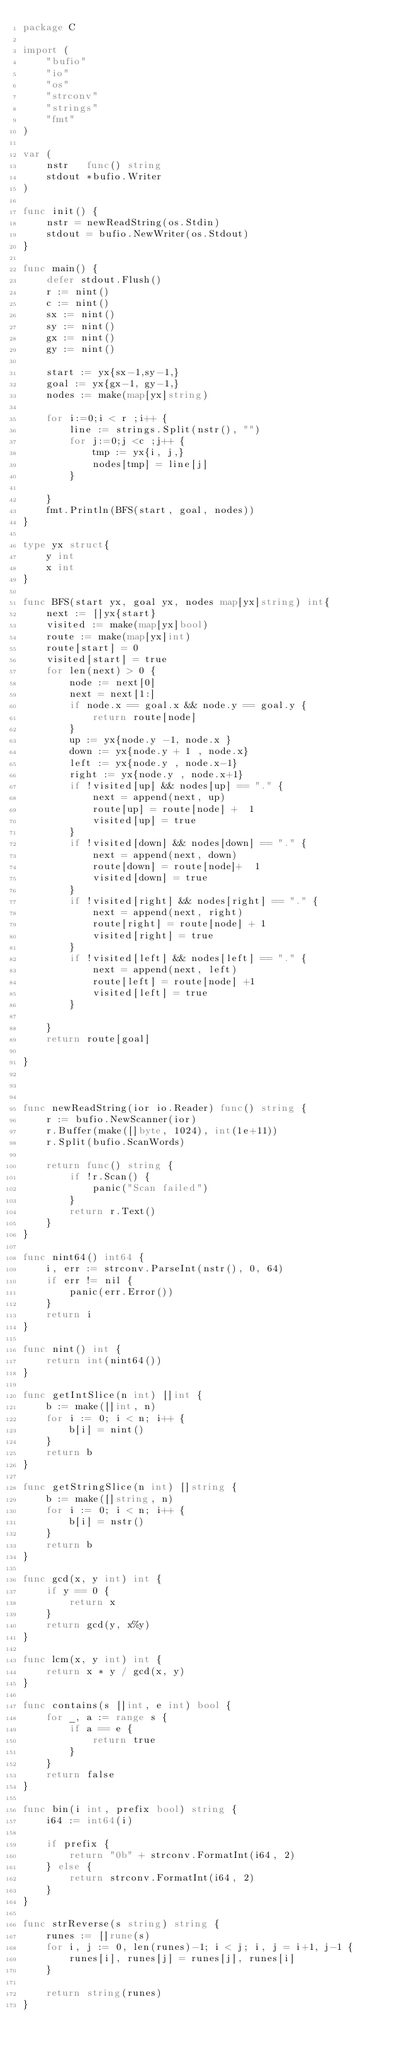<code> <loc_0><loc_0><loc_500><loc_500><_Go_>package C

import (
	"bufio"
	"io"
	"os"
	"strconv"
	"strings"
	"fmt"
)

var (
	nstr   func() string
	stdout *bufio.Writer
)

func init() {
	nstr = newReadString(os.Stdin)
	stdout = bufio.NewWriter(os.Stdout)
}

func main() {
	defer stdout.Flush()
	r := nint()
	c := nint()
	sx := nint()
	sy := nint()
	gx := nint()
	gy := nint()

	start := yx{sx-1,sy-1,}
	goal := yx{gx-1, gy-1,}
	nodes := make(map[yx]string)

	for i:=0;i < r ;i++ {
		line := strings.Split(nstr(), "")
		for j:=0;j <c ;j++ {
			tmp := yx{i, j,}
			nodes[tmp] = line[j]
		}

	}
	fmt.Println(BFS(start, goal, nodes))
}

type yx struct{
	y int
	x int
}

func BFS(start yx, goal yx, nodes map[yx]string) int{
	next := []yx{start}
	visited := make(map[yx]bool)
	route := make(map[yx]int)
	route[start] = 0
	visited[start] = true
	for len(next) > 0 {
		node := next[0]
		next = next[1:]
		if node.x == goal.x && node.y == goal.y {
			return route[node]
		}
		up := yx{node.y -1, node.x }
		down := yx{node.y + 1 , node.x}
		left := yx{node.y , node.x-1}
		right := yx{node.y , node.x+1}
		if !visited[up] && nodes[up] == "." {
			next = append(next, up)
			route[up] = route[node] +  1
			visited[up] = true
		}
		if !visited[down] && nodes[down] == "." {
			next = append(next, down)
			route[down] = route[node]+  1
			visited[down] = true
		}
		if !visited[right] && nodes[right] == "." {
			next = append(next, right)
			route[right] = route[node] + 1
			visited[right] = true
		}
		if !visited[left] && nodes[left] == "." {
			next = append(next, left)
			route[left] = route[node] +1
			visited[left] = true
		}

	}
	return route[goal]

}



func newReadString(ior io.Reader) func() string {
	r := bufio.NewScanner(ior)
	r.Buffer(make([]byte, 1024), int(1e+11))
	r.Split(bufio.ScanWords)

	return func() string {
		if !r.Scan() {
			panic("Scan failed")
		}
		return r.Text()
	}
}

func nint64() int64 {
	i, err := strconv.ParseInt(nstr(), 0, 64)
	if err != nil {
		panic(err.Error())
	}
	return i
}

func nint() int {
	return int(nint64())
}

func getIntSlice(n int) []int {
	b := make([]int, n)
	for i := 0; i < n; i++ {
		b[i] = nint()
	}
	return b
}

func getStringSlice(n int) []string {
	b := make([]string, n)
	for i := 0; i < n; i++ {
		b[i] = nstr()
	}
	return b
}

func gcd(x, y int) int {
	if y == 0 {
		return x
	}
	return gcd(y, x%y)
}

func lcm(x, y int) int {
	return x * y / gcd(x, y)
}

func contains(s []int, e int) bool {
	for _, a := range s {
		if a == e {
			return true
		}
	}
	return false
}

func bin(i int, prefix bool) string {
	i64 := int64(i)

	if prefix {
		return "0b" + strconv.FormatInt(i64, 2)
	} else {
		return strconv.FormatInt(i64, 2)
	}
}

func strReverse(s string) string {
	runes := []rune(s)
	for i, j := 0, len(runes)-1; i < j; i, j = i+1, j-1 {
		runes[i], runes[j] = runes[j], runes[i]
	}

	return string(runes)
}

</code> 